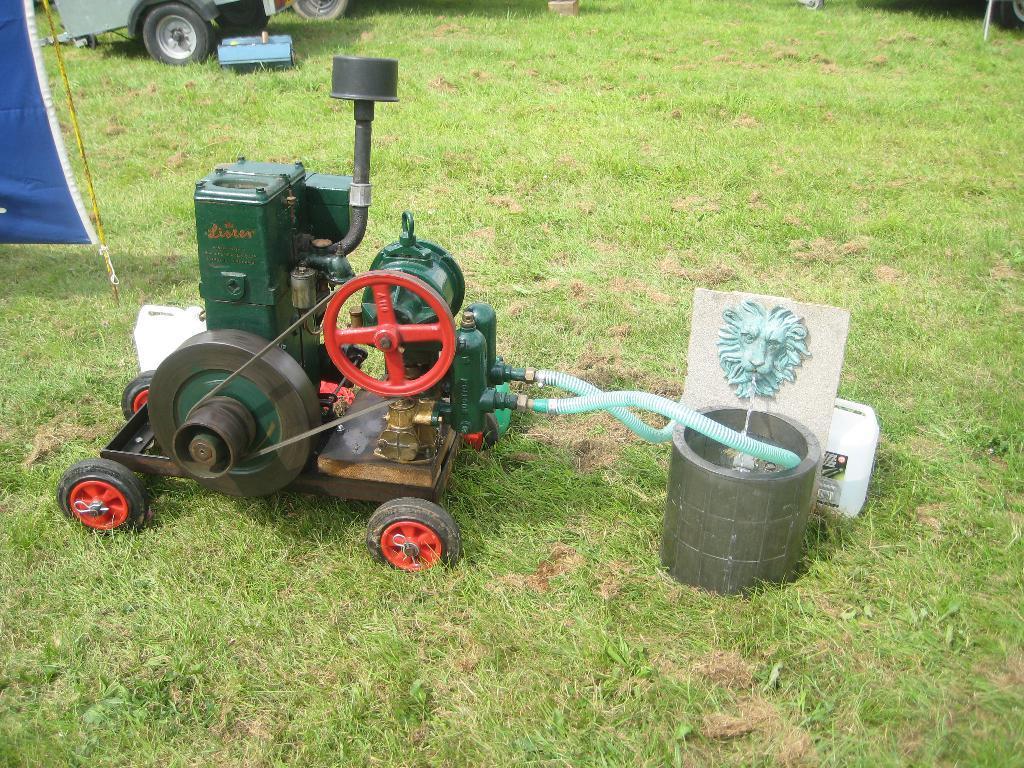Could you give a brief overview of what you see in this image? In the picture I can see a machine which has pipes attached to it. In the background I can see a vehicle, the grass and some other objects on the ground. 